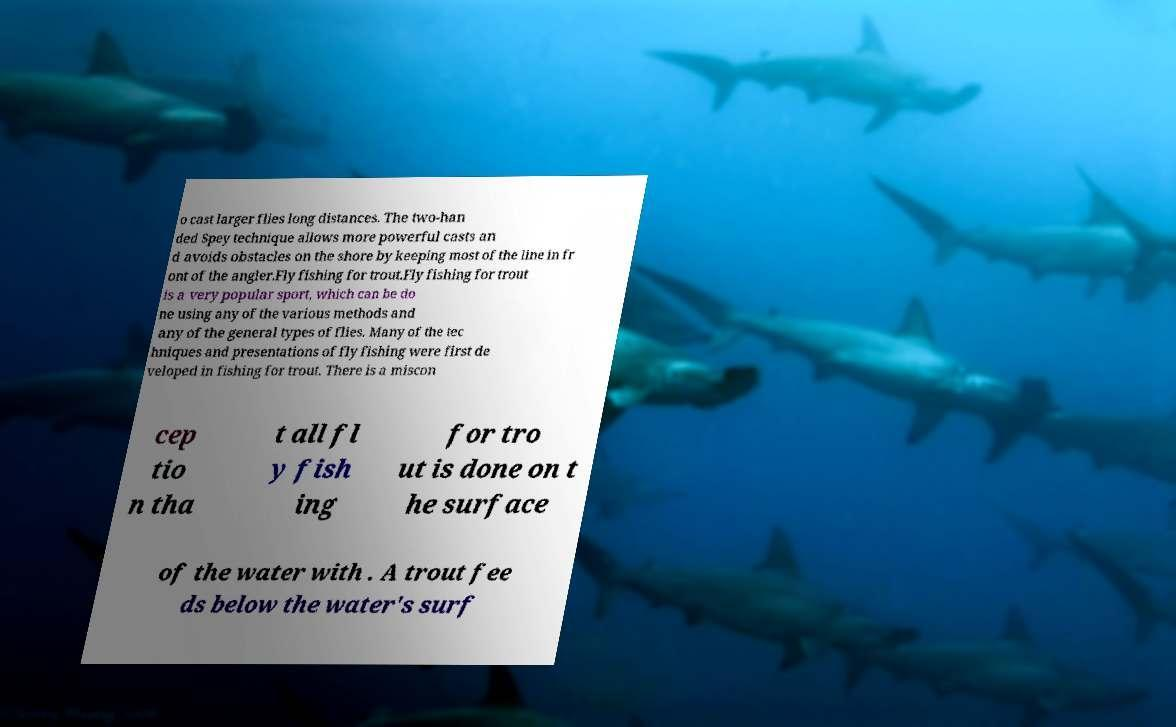Please identify and transcribe the text found in this image. o cast larger flies long distances. The two-han ded Spey technique allows more powerful casts an d avoids obstacles on the shore by keeping most of the line in fr ont of the angler.Fly fishing for trout.Fly fishing for trout is a very popular sport, which can be do ne using any of the various methods and any of the general types of flies. Many of the tec hniques and presentations of fly fishing were first de veloped in fishing for trout. There is a miscon cep tio n tha t all fl y fish ing for tro ut is done on t he surface of the water with . A trout fee ds below the water's surf 